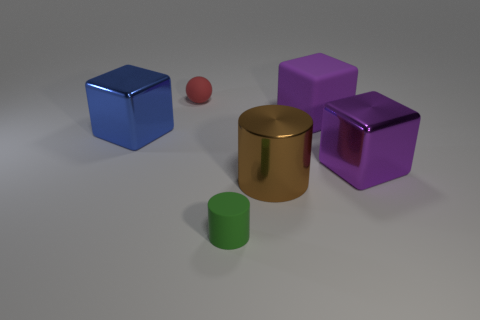Subtract all big purple metallic blocks. How many blocks are left? 2 Add 3 green things. How many objects exist? 9 Subtract 3 cubes. How many cubes are left? 0 Subtract all tiny brown rubber blocks. Subtract all metal blocks. How many objects are left? 4 Add 6 blue shiny objects. How many blue shiny objects are left? 7 Add 1 big purple rubber cubes. How many big purple rubber cubes exist? 2 Subtract all blue cubes. How many cubes are left? 2 Subtract 0 cyan cylinders. How many objects are left? 6 Subtract all balls. How many objects are left? 5 Subtract all cyan blocks. Subtract all gray balls. How many blocks are left? 3 